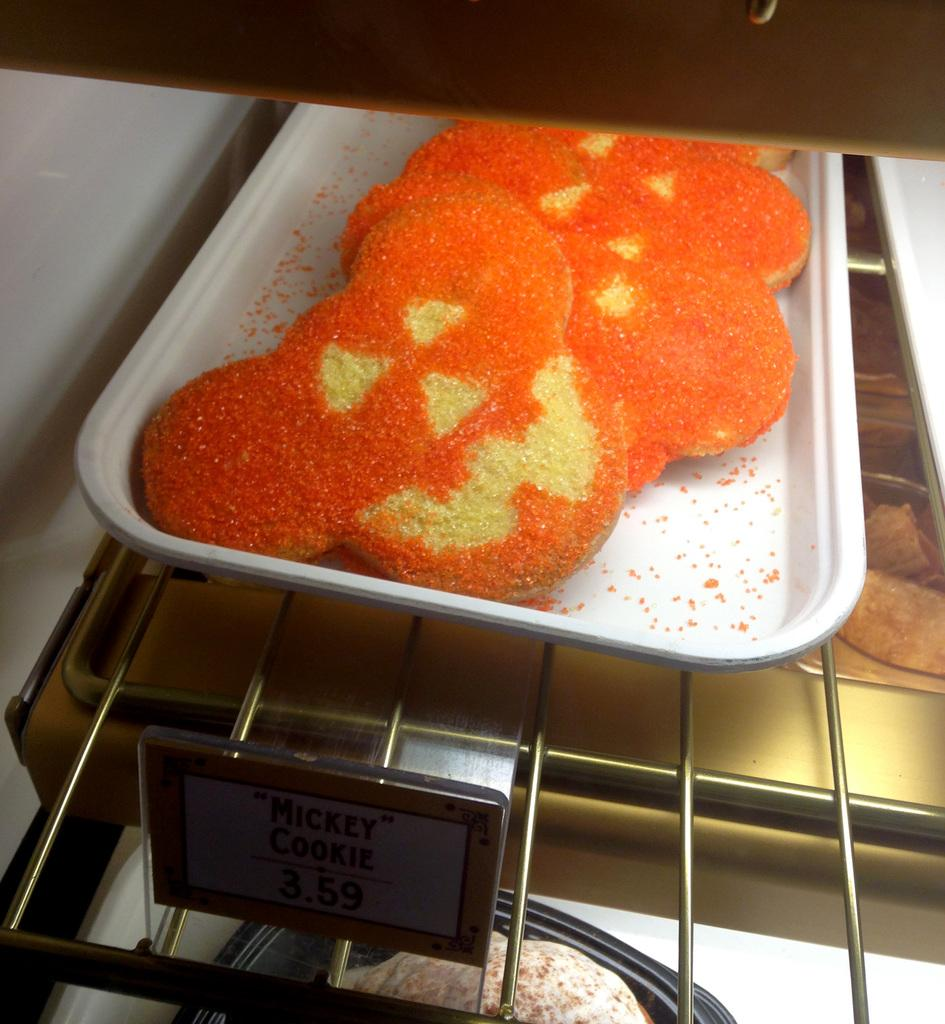What type of appliance is present in the image? The image contains a microwave oven. What else can be seen in the image besides the microwave oven? There are food items, a platter, and grills visible in the image. Is there any identification or labeling present in the image? Yes, there is a nameplate in the image. How many kittens are playing with a duck and a kite in the image? There are no kittens, ducks, or kites present in the image. 